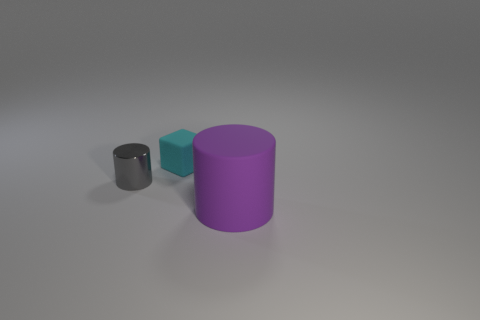Add 2 tiny cyan blocks. How many objects exist? 5 Subtract all blocks. How many objects are left? 2 Add 3 tiny gray cylinders. How many tiny gray cylinders are left? 4 Add 3 tiny cyan cubes. How many tiny cyan cubes exist? 4 Subtract 1 gray cylinders. How many objects are left? 2 Subtract all tiny gray rubber spheres. Subtract all cyan rubber objects. How many objects are left? 2 